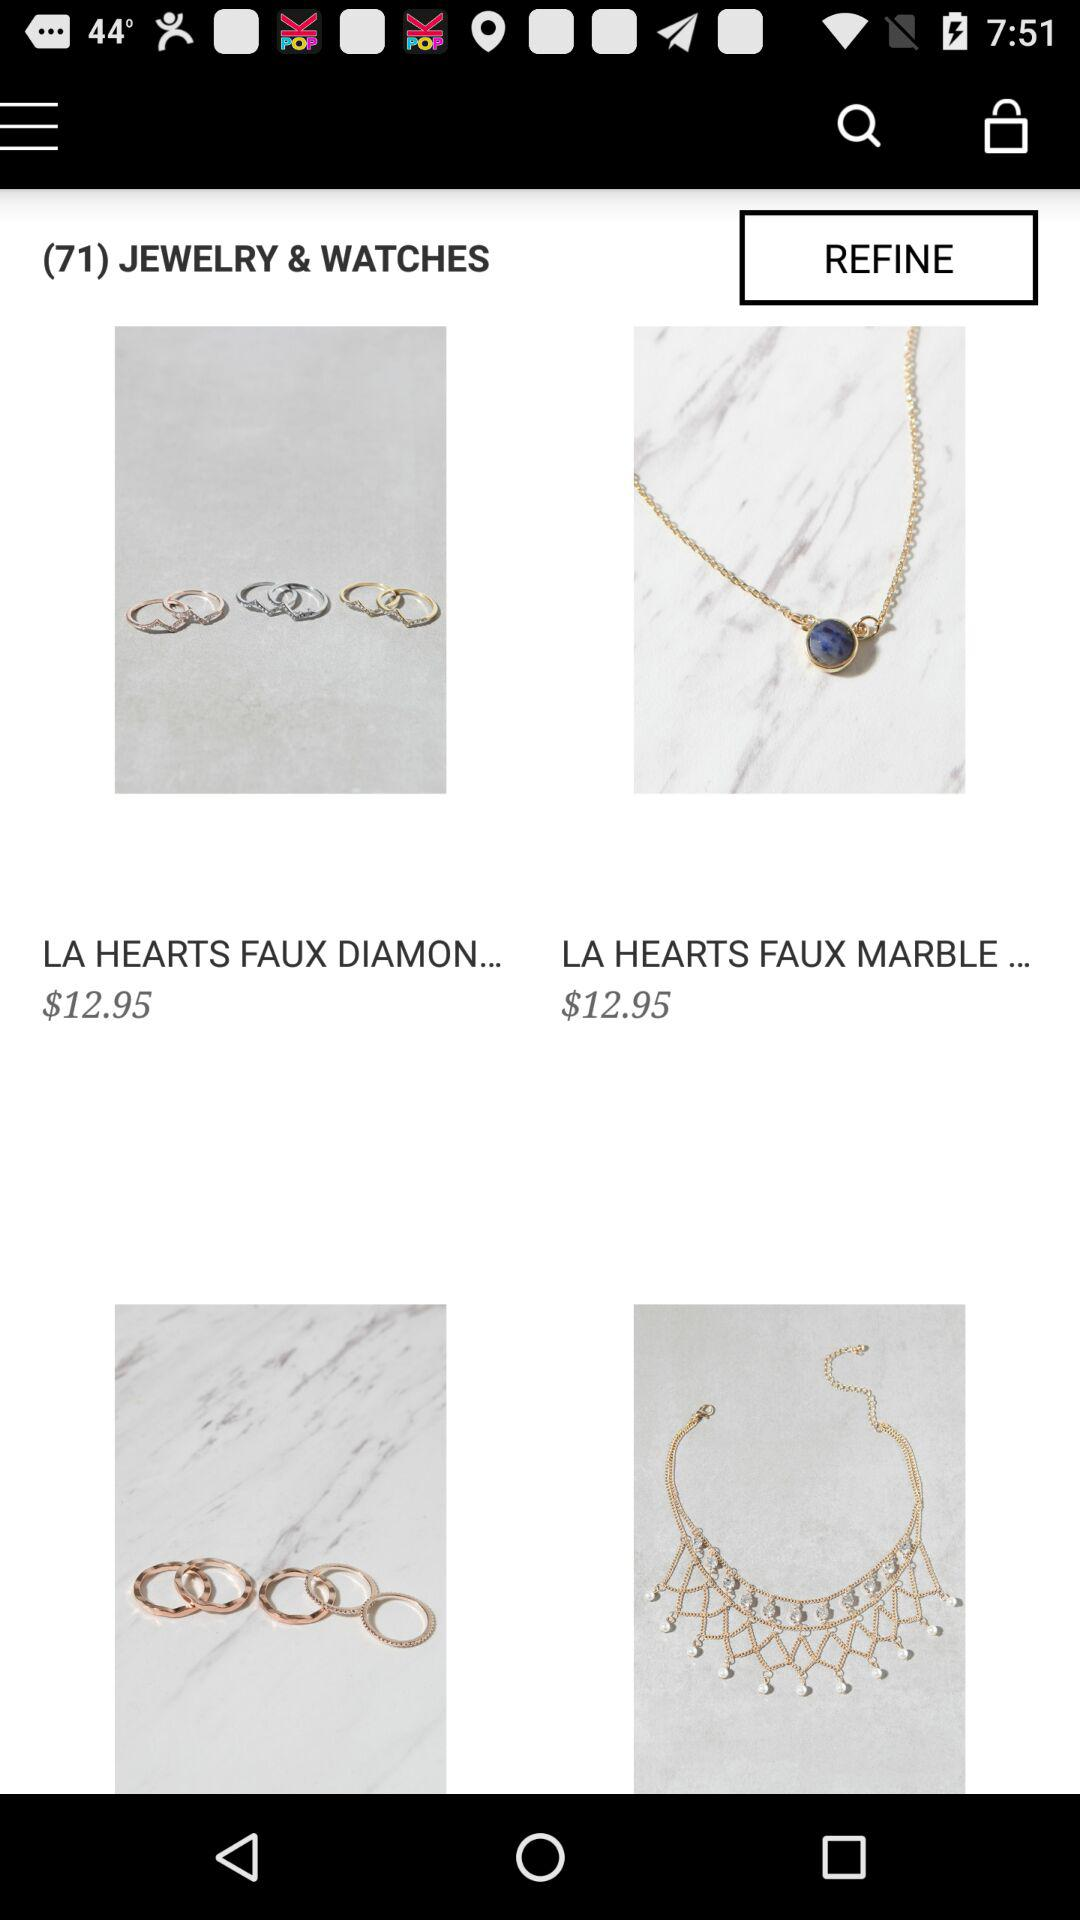How many items are on the first page of results?
Answer the question using a single word or phrase. 4 